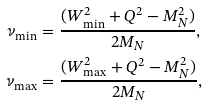Convert formula to latex. <formula><loc_0><loc_0><loc_500><loc_500>\nu _ { \min } & = \frac { ( W ^ { 2 } _ { \min } + Q ^ { 2 } - M _ { N } ^ { 2 } ) } { 2 M _ { N } } , \\ \nu _ { \max } & = \frac { ( W ^ { 2 } _ { \max } + Q ^ { 2 } - M _ { N } ^ { 2 } ) } { 2 M _ { N } } ,</formula> 